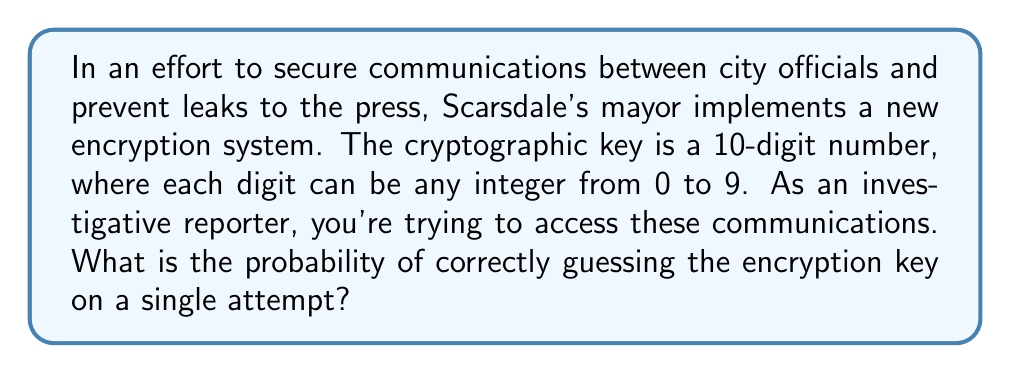What is the answer to this math problem? To solve this problem, we need to follow these steps:

1) First, let's determine the total number of possible keys:
   - Each digit can be any number from 0 to 9, so there are 10 possibilities for each digit.
   - The key is 10 digits long.
   - Using the multiplication principle, the total number of possible keys is:
     $$ 10^{10} = 10,000,000,000 $$

2) The probability of correctly guessing the key is the number of correct keys (which is 1) divided by the total number of possible keys:

   $$ P(\text{correct guess}) = \frac{\text{number of correct keys}}{\text{total number of possible keys}} = \frac{1}{10^{10}} $$

3) This can be simplified to:

   $$ P(\text{correct guess}) = 10^{-10} = 0.0000000001 $$

Therefore, the probability of correctly guessing the encryption key on a single attempt is $10^{-10}$ or 0.0000000001 or 1 in 10 billion.
Answer: $10^{-10}$ 